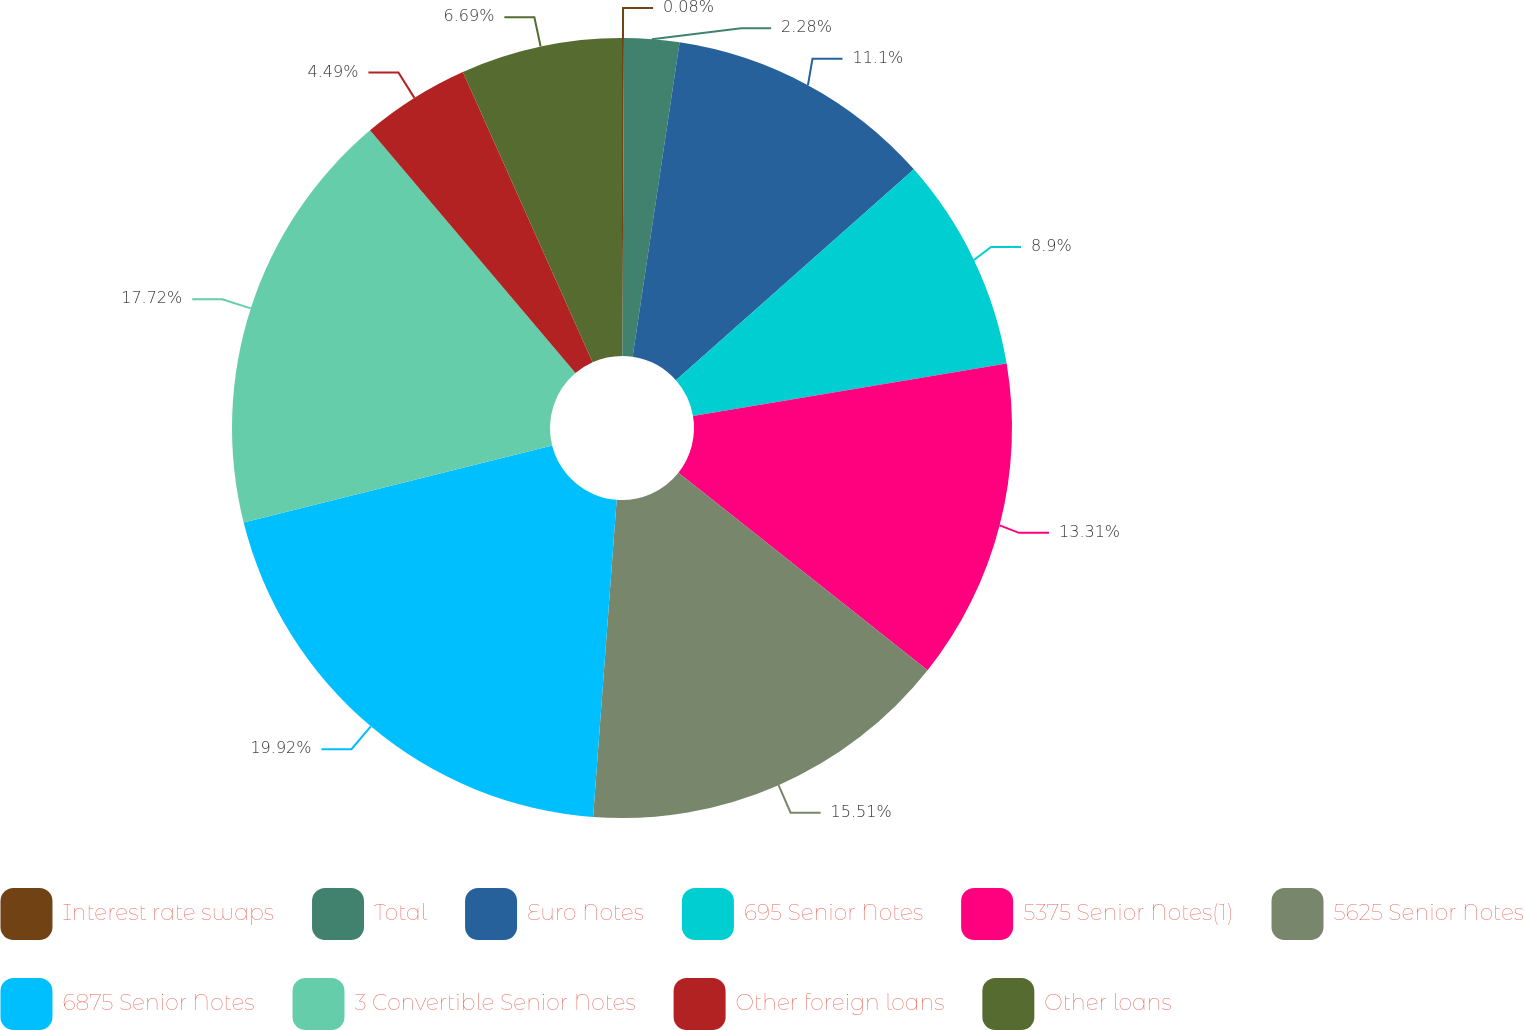<chart> <loc_0><loc_0><loc_500><loc_500><pie_chart><fcel>Interest rate swaps<fcel>Total<fcel>Euro Notes<fcel>695 Senior Notes<fcel>5375 Senior Notes(1)<fcel>5625 Senior Notes<fcel>6875 Senior Notes<fcel>3 Convertible Senior Notes<fcel>Other foreign loans<fcel>Other loans<nl><fcel>0.08%<fcel>2.28%<fcel>11.1%<fcel>8.9%<fcel>13.31%<fcel>15.51%<fcel>19.92%<fcel>17.72%<fcel>4.49%<fcel>6.69%<nl></chart> 